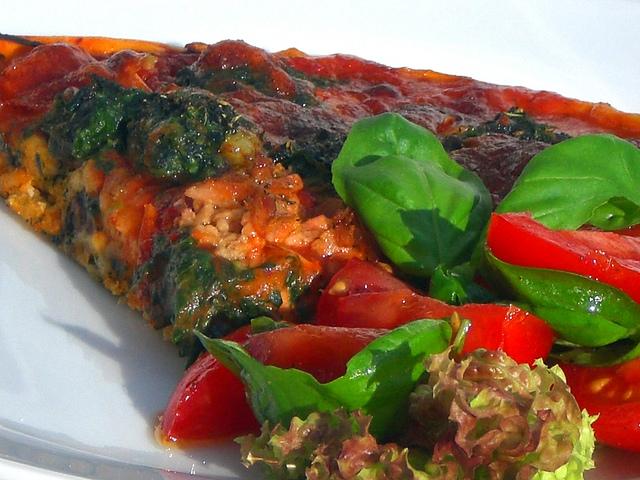Is this a healthy meal?
Short answer required. Yes. What is the red food?
Write a very short answer. Tomatoes. Is there spinach on this dish?
Quick response, please. Yes. 